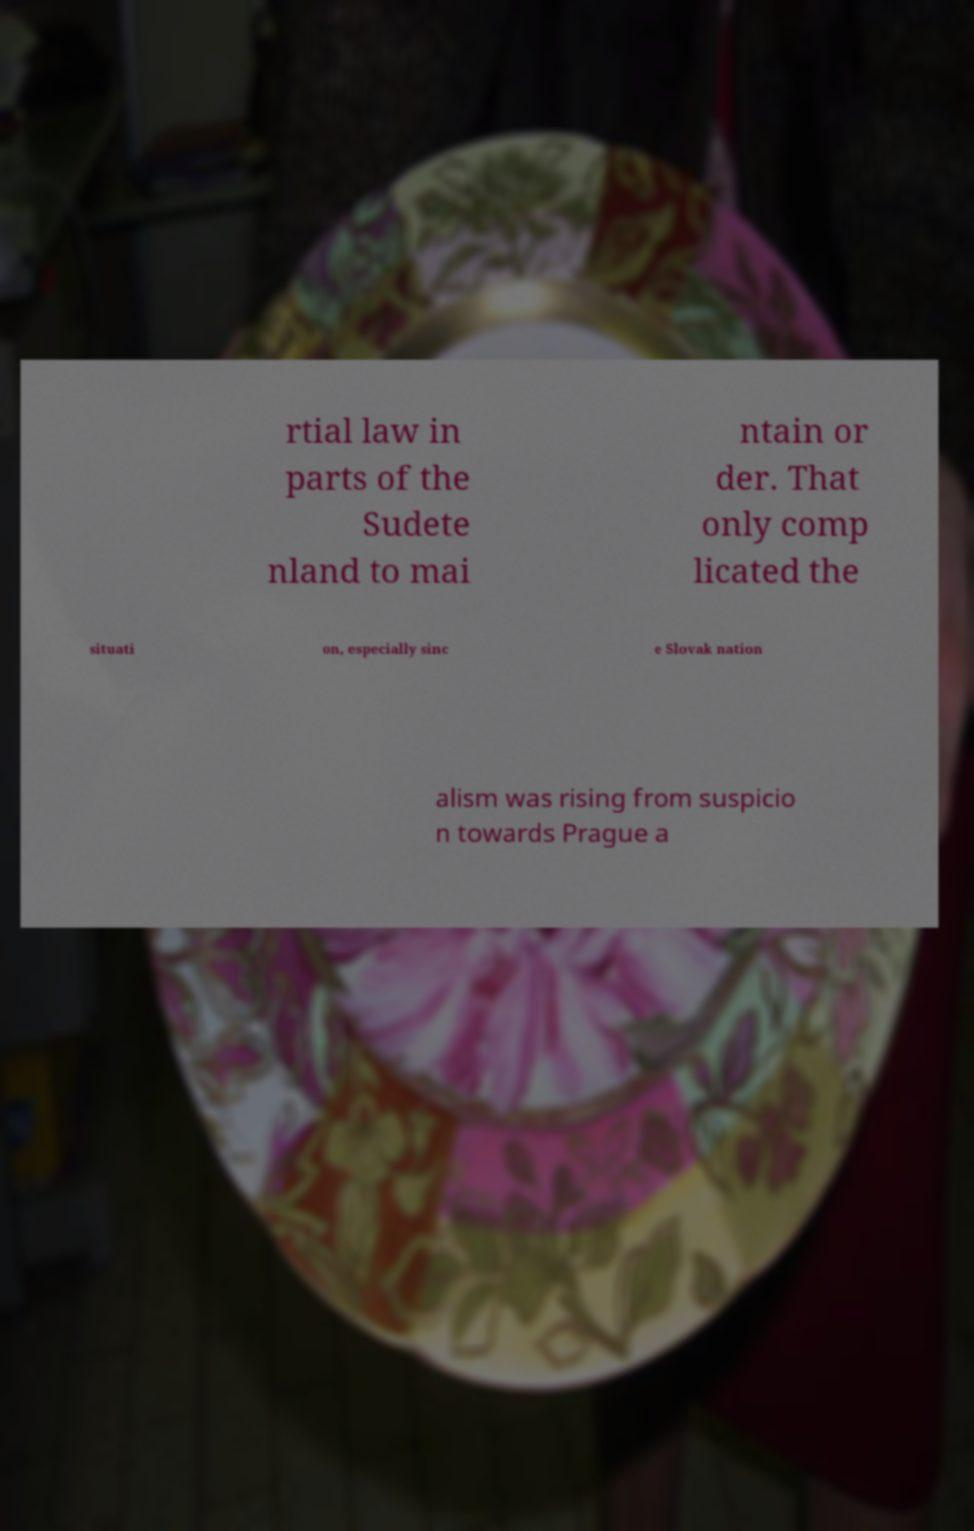Can you read and provide the text displayed in the image?This photo seems to have some interesting text. Can you extract and type it out for me? rtial law in parts of the Sudete nland to mai ntain or der. That only comp licated the situati on, especially sinc e Slovak nation alism was rising from suspicio n towards Prague a 